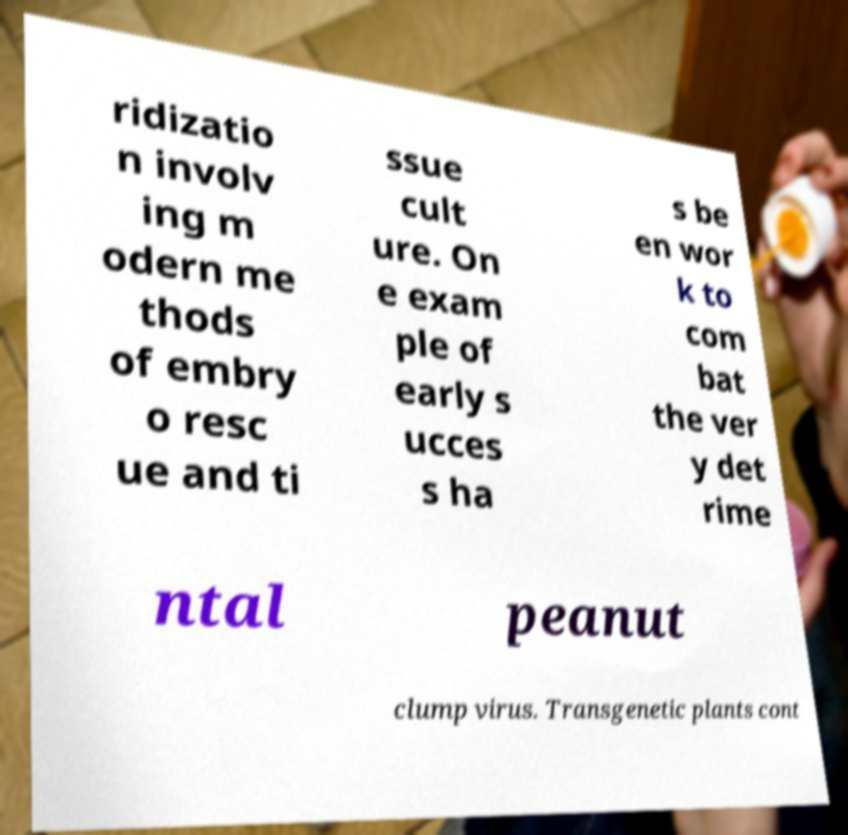I need the written content from this picture converted into text. Can you do that? ridizatio n involv ing m odern me thods of embry o resc ue and ti ssue cult ure. On e exam ple of early s ucces s ha s be en wor k to com bat the ver y det rime ntal peanut clump virus. Transgenetic plants cont 